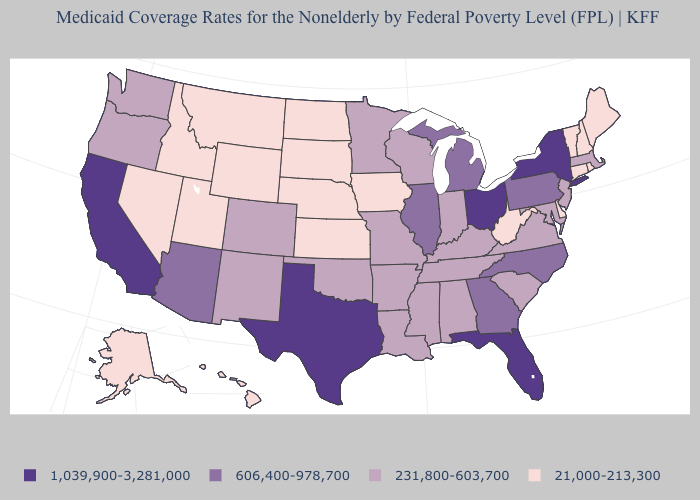Does Delaware have the same value as Virginia?
Short answer required. No. Among the states that border Virginia , does West Virginia have the lowest value?
Short answer required. Yes. What is the value of New York?
Short answer required. 1,039,900-3,281,000. Name the states that have a value in the range 606,400-978,700?
Write a very short answer. Arizona, Georgia, Illinois, Michigan, North Carolina, Pennsylvania. Name the states that have a value in the range 231,800-603,700?
Concise answer only. Alabama, Arkansas, Colorado, Indiana, Kentucky, Louisiana, Maryland, Massachusetts, Minnesota, Mississippi, Missouri, New Jersey, New Mexico, Oklahoma, Oregon, South Carolina, Tennessee, Virginia, Washington, Wisconsin. Does the first symbol in the legend represent the smallest category?
Write a very short answer. No. Which states have the lowest value in the West?
Keep it brief. Alaska, Hawaii, Idaho, Montana, Nevada, Utah, Wyoming. Name the states that have a value in the range 1,039,900-3,281,000?
Quick response, please. California, Florida, New York, Ohio, Texas. Does New Hampshire have the lowest value in the USA?
Give a very brief answer. Yes. How many symbols are there in the legend?
Short answer required. 4. Is the legend a continuous bar?
Concise answer only. No. Among the states that border Wyoming , which have the lowest value?
Be succinct. Idaho, Montana, Nebraska, South Dakota, Utah. Is the legend a continuous bar?
Quick response, please. No. Name the states that have a value in the range 21,000-213,300?
Keep it brief. Alaska, Connecticut, Delaware, Hawaii, Idaho, Iowa, Kansas, Maine, Montana, Nebraska, Nevada, New Hampshire, North Dakota, Rhode Island, South Dakota, Utah, Vermont, West Virginia, Wyoming. What is the lowest value in the Northeast?
Give a very brief answer. 21,000-213,300. 